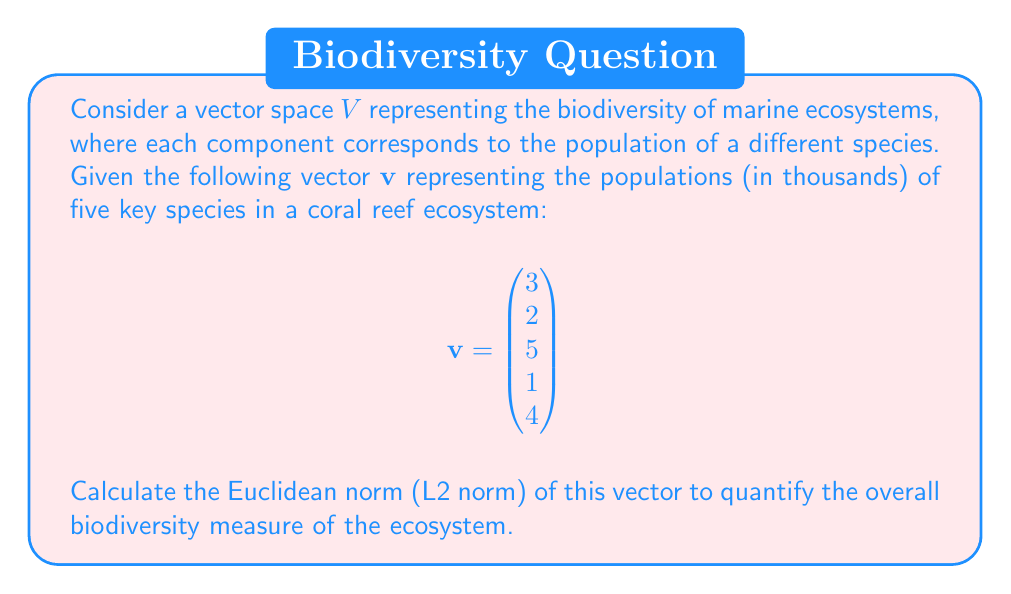Could you help me with this problem? To calculate the Euclidean norm (L2 norm) of the vector $\mathbf{v}$, we follow these steps:

1) The Euclidean norm is defined as:

   $$\|\mathbf{v}\|_2 = \sqrt{\sum_{i=1}^n |v_i|^2}$$

   where $n$ is the number of components in the vector.

2) In this case, we have:

   $$\|\mathbf{v}\|_2 = \sqrt{|3|^2 + |2|^2 + |5|^2 + |1|^2 + |4|^2}$$

3) Simplify the squares:

   $$\|\mathbf{v}\|_2 = \sqrt{9 + 4 + 25 + 1 + 16}$$

4) Sum the values under the square root:

   $$\|\mathbf{v}\|_2 = \sqrt{55}$$

5) Simplify the square root:

   $$\|\mathbf{v}\|_2 = \sqrt{55} \approx 7.416$$

The Euclidean norm provides a single value that represents the magnitude of the vector, which in this context can be interpreted as a measure of overall biodiversity. A larger norm generally indicates higher biodiversity, although it's important to note that this simplification doesn't account for the relative importance or rarity of different species.
Answer: The Euclidean norm (L2 norm) of the vector $\mathbf{v}$ is $\sqrt{55} \approx 7.416$. 